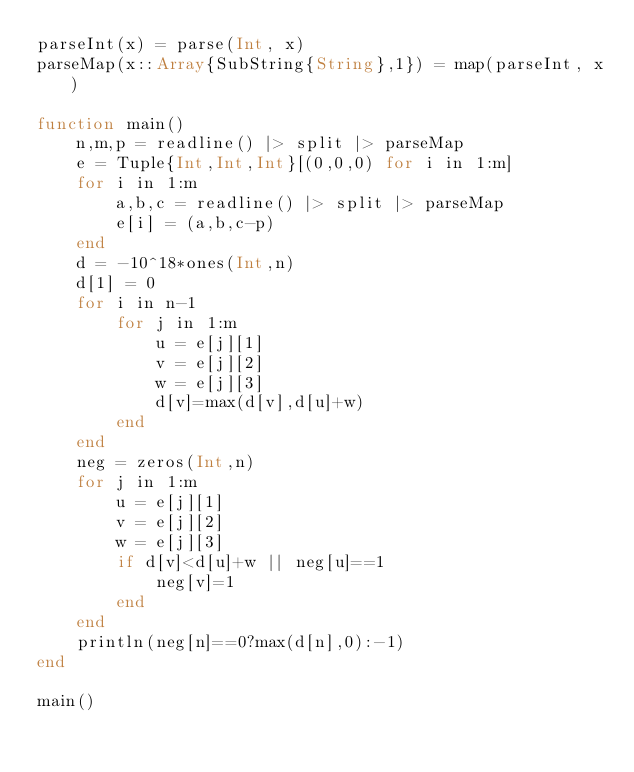<code> <loc_0><loc_0><loc_500><loc_500><_Julia_>parseInt(x) = parse(Int, x)
parseMap(x::Array{SubString{String},1}) = map(parseInt, x)

function main()
	n,m,p = readline() |> split |> parseMap
	e = Tuple{Int,Int,Int}[(0,0,0) for i in 1:m]
	for i in 1:m
		a,b,c = readline() |> split |> parseMap
		e[i] = (a,b,c-p)
	end
	d = -10^18*ones(Int,n)
	d[1] = 0
	for i in n-1
		for j in 1:m
			u = e[j][1]
			v = e[j][2]
			w = e[j][3]
			d[v]=max(d[v],d[u]+w)
		end
	end
	neg = zeros(Int,n)
	for j in 1:m		
		u = e[j][1]
		v = e[j][2]
		w = e[j][3]
		if d[v]<d[u]+w || neg[u]==1
			neg[v]=1
		end
	end
	println(neg[n]==0?max(d[n],0):-1)
end

main()</code> 